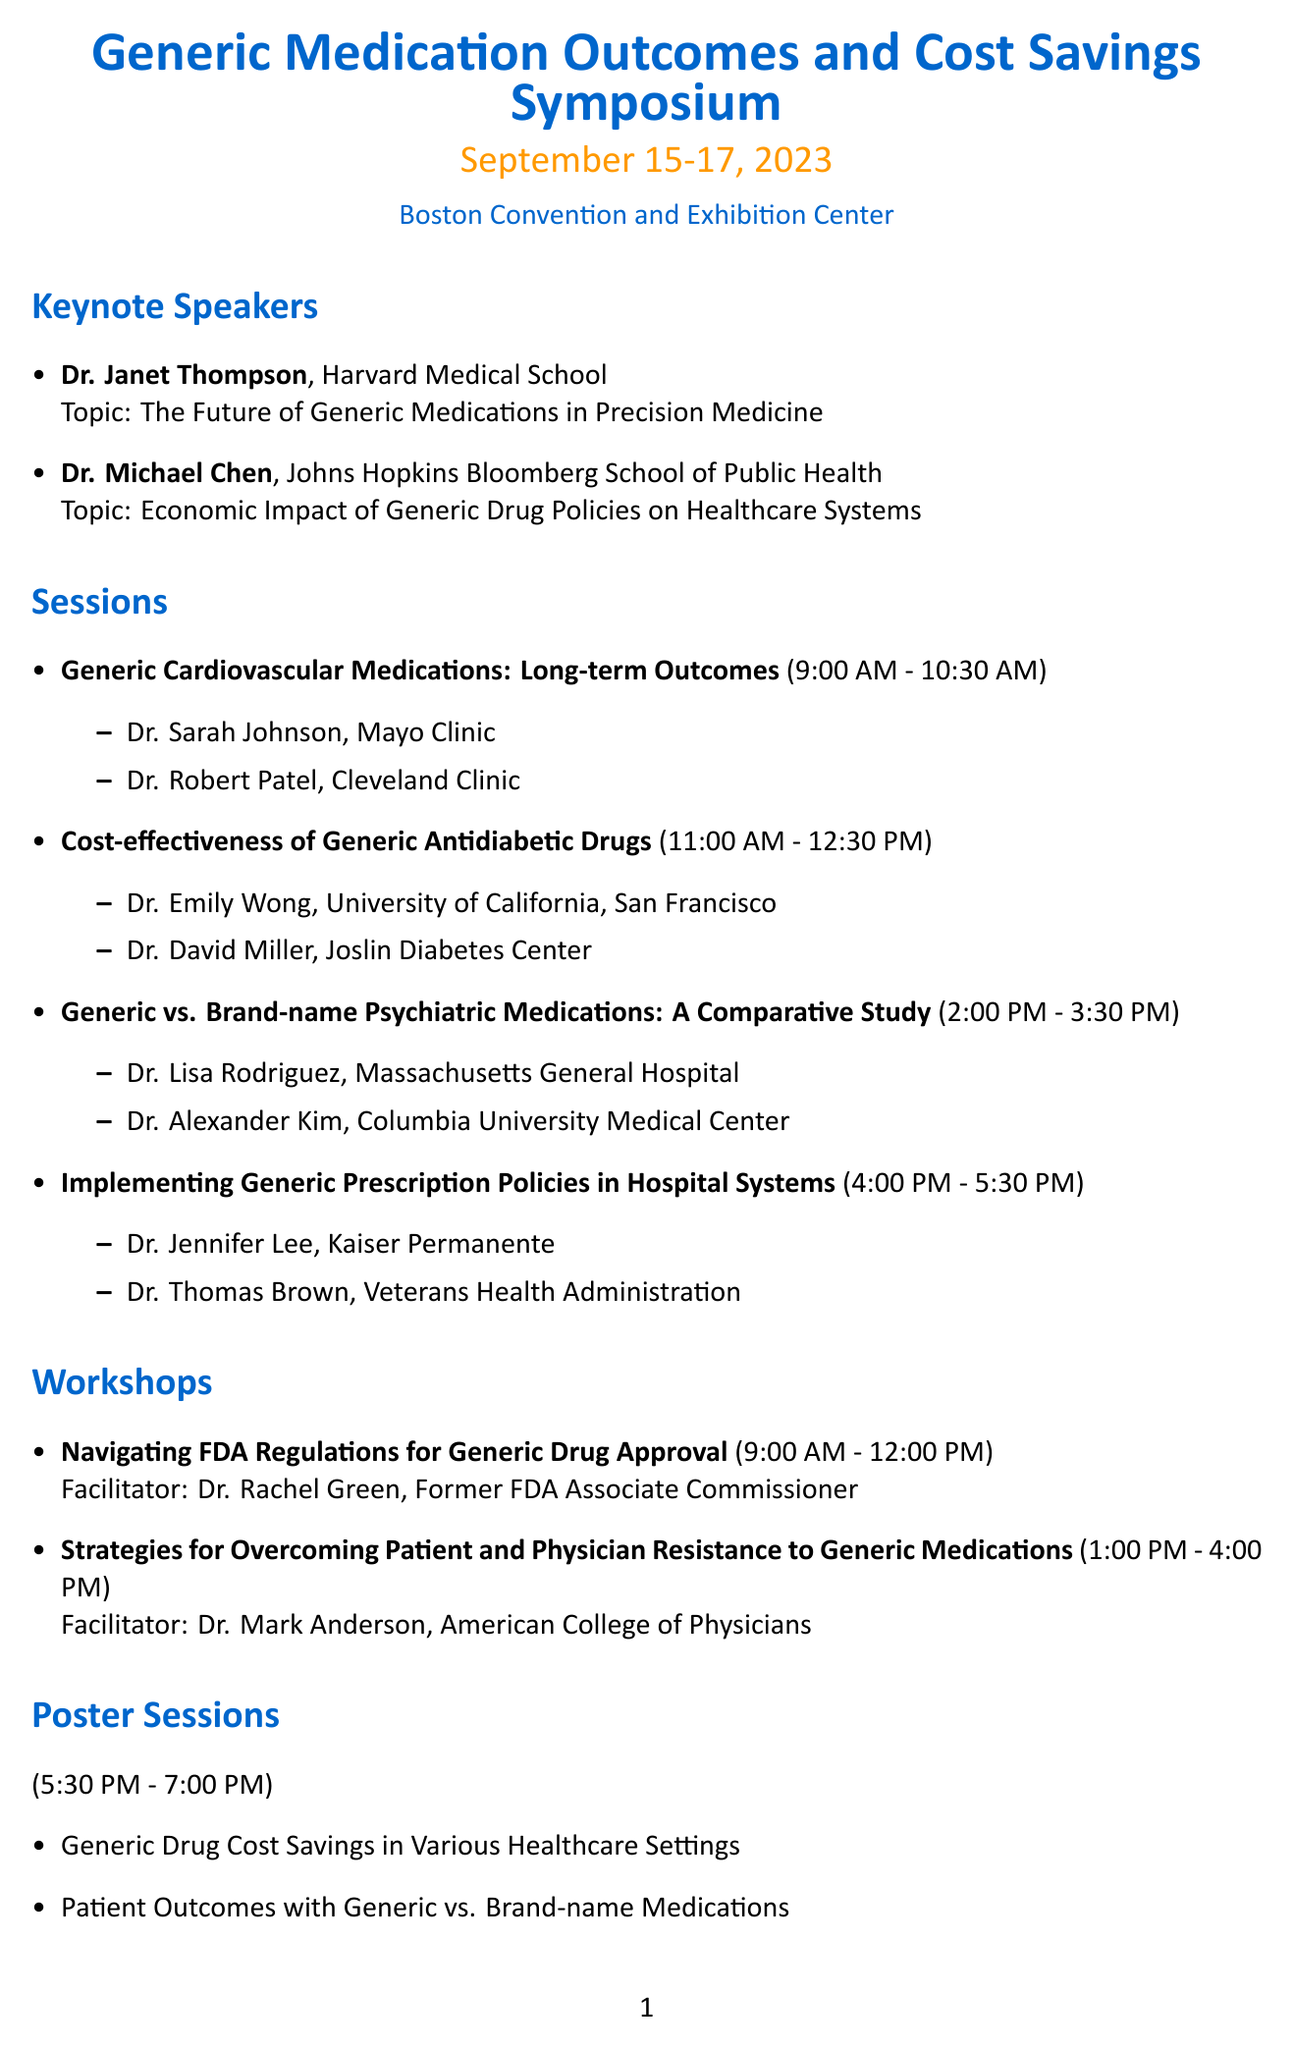What are the dates of the conference? The conference dates are specified in the document as September 15-17, 2023.
Answer: September 15-17, 2023 Who is the keynote speaker from Harvard Medical School? The document lists Dr. Janet Thompson as the keynote speaker affiliated with Harvard Medical School.
Answer: Dr. Janet Thompson What time does the workshop on FDA regulations start? The document provides the start time for the workshop on FDA regulations, which is 9:00 AM.
Answer: 9:00 AM How many keynote speakers are there? The document outlines two individuals as keynote speakers for the conference.
Answer: 2 What is the title of the session led by Dr. Sarah Johnson? The document states that Dr. Sarah Johnson will present on "Generic Cardiovascular Medications: Long-term Outcomes."
Answer: Generic Cardiovascular Medications: Long-term Outcomes What is the venue for the Welcome Reception? The document specifies that the Welcome Reception will take place at the Seaport Hotel.
Answer: Seaport Hotel What time does the Generic Medication Industry Dinner end? The document indicates that the Generic Medication Industry Dinner is scheduled to end at 10:00 PM.
Answer: 10:00 PM Who facilitates the workshop on strategies for overcoming resistance to generic medications? The document lists Dr. Mark Anderson as the facilitator for this workshop.
Answer: Dr. Mark Anderson 